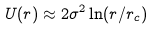<formula> <loc_0><loc_0><loc_500><loc_500>U ( r ) \approx 2 \sigma ^ { 2 } \ln ( r / r _ { c } )</formula> 